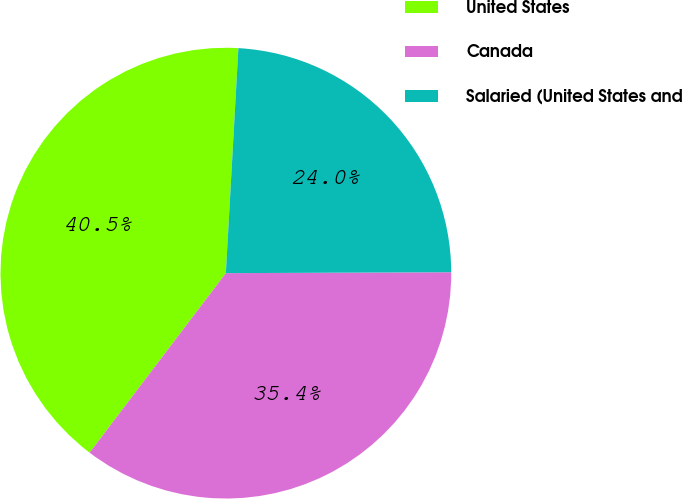Convert chart to OTSL. <chart><loc_0><loc_0><loc_500><loc_500><pie_chart><fcel>United States<fcel>Canada<fcel>Salaried (United States and<nl><fcel>40.55%<fcel>35.4%<fcel>24.05%<nl></chart> 